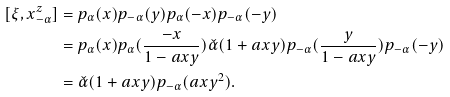Convert formula to latex. <formula><loc_0><loc_0><loc_500><loc_500>[ \xi , x ^ { z } _ { - \alpha } ] & = p _ { \alpha } ( x ) p _ { - \alpha } ( y ) p _ { \alpha } ( - x ) p _ { - \alpha } ( - y ) \\ & = p _ { \alpha } ( x ) p _ { \alpha } ( \frac { - x } { 1 - a x y } ) \check { \alpha } ( 1 + a x y ) p _ { - \alpha } ( \frac { y } { 1 - a x y } ) p _ { - \alpha } ( - y ) \\ & = \check { \alpha } ( 1 + a x y ) p _ { - \alpha } ( a x y ^ { 2 } ) .</formula> 